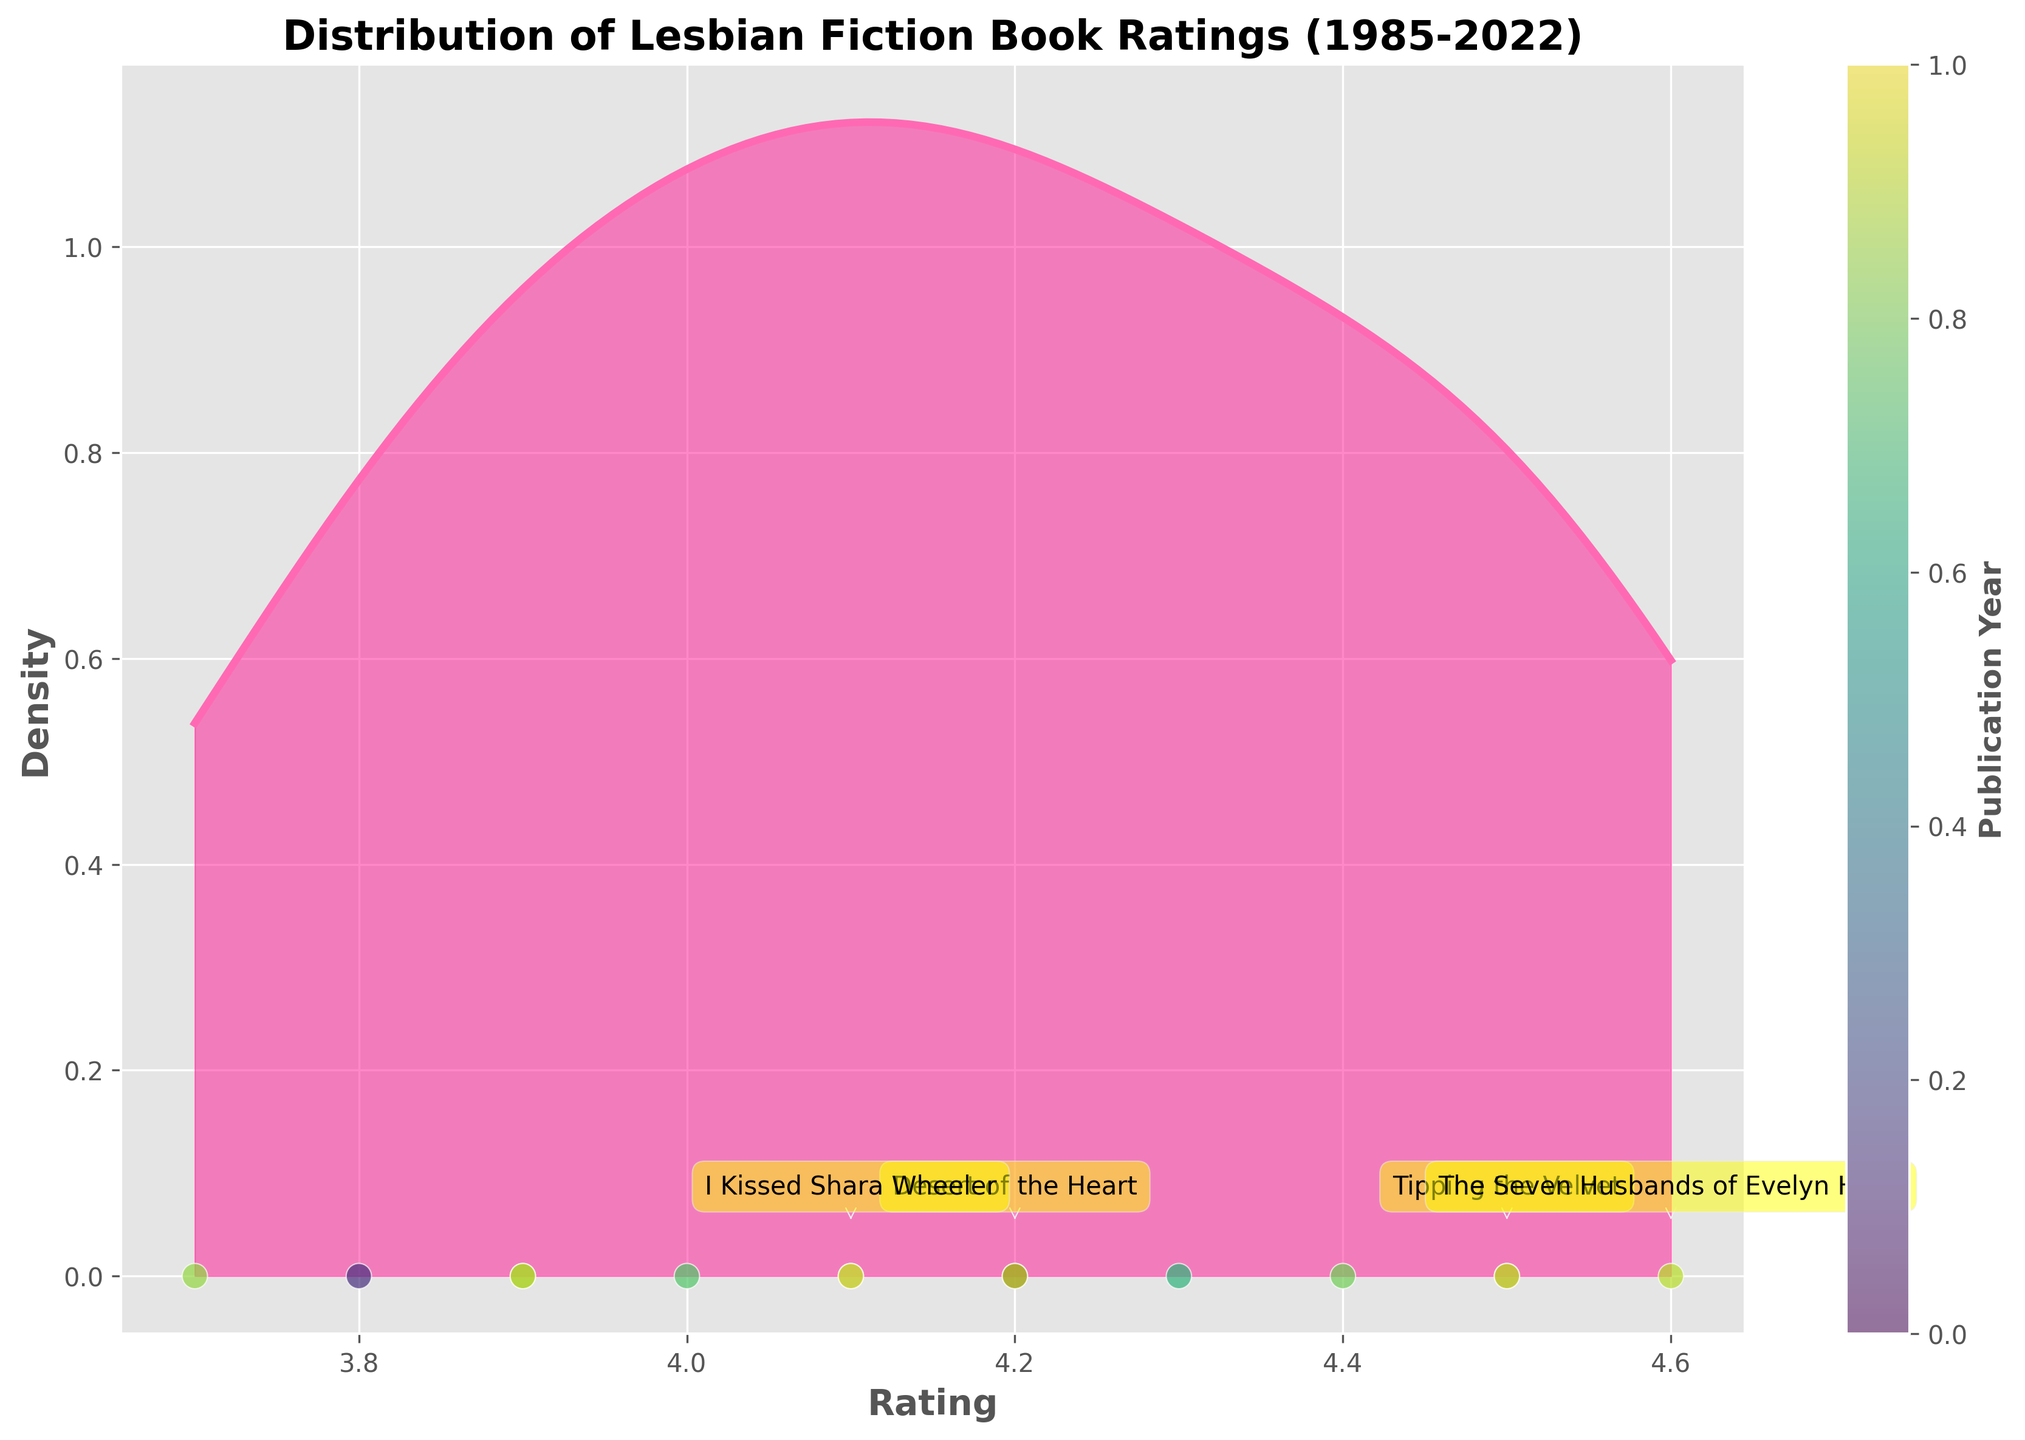What is the title of the plot? The title of the plot is shown at the top. It indicates what the plot is about. In this case, it reads "Distribution of Lesbian Fiction Book Ratings (1985-2022)".
Answer: Distribution of Lesbian Fiction Book Ratings (1985-2022) What does the x-axis represent? The x-axis represents the book ratings in the plot. This can be seen by looking at the label on the horizontal axis which reads "Rating".
Answer: Rating How many books have a rating of 4.5? The number of books with a rating of 4.5 can be identified by examining the scatter points on the plot. There are two such points corresponding to the ratings of "Tipping the Velvet" (1997) and "One Last Stop" (2021).
Answer: 2 Which book from the plot has the highest rating? The highest rating on the plot can be seen as 4.6, which corresponds to "The Seven Husbands of Evelyn Hugo" published in 2018. This is identified by the scatter points and annotated titles.
Answer: The Seven Husbands of Evelyn Hugo How is the density of ratings for books published around the year 2000 compared to 2020? To compare the density of ratings for books published around these years, observe the clustering and height of density on the plot. Ratings around 2000 show moderate density while those around 2020 show a higher density.
Answer: Higher around 2020 What is the color used to represent the publication years, and how does it vary across the points? The color used to represent publication years varies across the points, with a color gradient from violet to yellow, reflective of the publication year, aided by the color bar.
Answer: Violet to yellow gradient Which year has the most highly rated book, and what is the rating? Observing the scatter points, 2018 has the most highly rated book with a rating of 4.6, which is "The Seven Husbands of Evelyn Hugo".
Answer: 2018, rating 4.6 Where is the peak of the density plot located and what does it imply? The peak of the density plot is located around a rating of 4.0 - 4.2. This implies that the greatest density of book ratings in this dataset lies within this range.
Answer: Around 4.0 - 4.2 What symbolic feature is used to highlight notable books, and can you name one of them? Notable books are highlighted using annotations with a round, padded yellow box and an arrow pointing to the specific data point. One such notable book is "Desert of the Heart" (1985).
Answer: Annotations with a round, padded yellow box and arrow; "Desert of the Heart" How does the density change as the rating increases from 3.7 to 4.6? The density generally starts lower at 3.7, rises to a peak around 4.0 - 4.2, and falls again as it approaches 4.6. This shows a higher concentration of ratings around the middle range.
Answer: Low to peak around 4.0 - 4.2, then decreases 